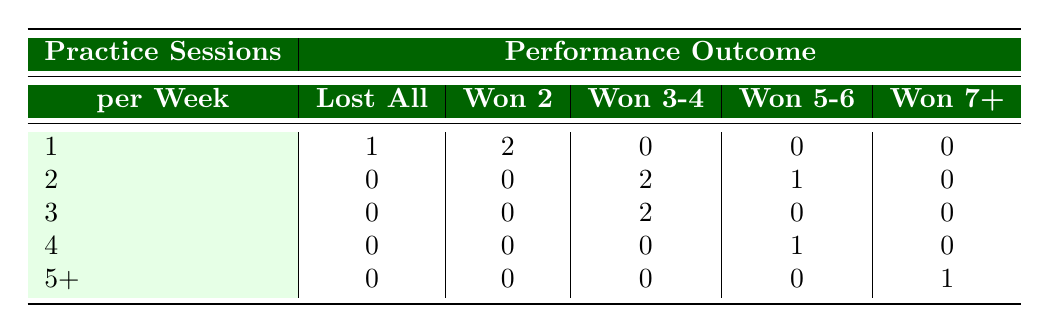What is the number of teams that lost all their matches? According to the table, there is 1 team that lost all matches listed under the "Lost All" column with 1 session per week.
Answer: 1 How many teams practiced twice a week? By examining the "Practice Sessions" row for "2", I see that there are 3 teams listed (Maplewood Marauders, Hilltop Heroes, and the one with "Won 3-4") for that category.
Answer: 3 Which practice session group has the most wins? Looking at the "Won 7+" column, it is evident that only 1 team practiced 5 sessions per week and achieved 7 wins, which is the highest win count.
Answer: 5 sessions What is the total number of teams that won 3 or more matches? To find this, I will add the number of teams in the "Won 3-4" and "Won 5-6" columns. There are 2 teams winning 3-4 matches and 1 team winning 5-6 matches, making a total of 3.
Answer: 3 Did any teams practice 4 times a week and won 2 matches? Checking the row for 4 practice sessions, it shows that no teams are listed in the "Won 2" column. Hence, the answer is no.
Answer: No What is the average number of matches won by teams practicing once a week? From the table, there are 2 instances of "Won 2 Matches". I sum these wins (2) and divide by the number of teams (2) who practiced once a week, resulting in an average of 1 win per team.
Answer: 1 Are there more teams practicing three times a week or two times a week? In the table, there are 2 teams practicing 2 times (found under the "2" row) and 2 teams for the "3" sessions row. So, there is a tie.
Answer: Tie How many wins are there in total from teams that practiced 3 times a week? In the "3" session row, there are 2 teams won 3-4 matches (4 total wins). Thus, the answer is a sum of the counting.
Answer: 4 Which group had the highest number of matches won, and how many did they win? The team in the "Won 7+" category practiced 5 sessions a week and won a total of 7 matches, making it the highest number.
Answer: 7 